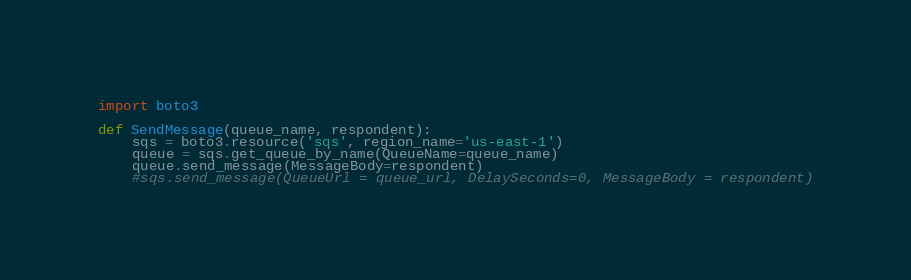Convert code to text. <code><loc_0><loc_0><loc_500><loc_500><_Python_>import boto3

def SendMessage(queue_name, respondent):
    sqs = boto3.resource('sqs', region_name='us-east-1')
    queue = sqs.get_queue_by_name(QueueName=queue_name)
    queue.send_message(MessageBody=respondent)
    #sqs.send_message(QueueUrl = queue_url, DelaySeconds=0, MessageBody = respondent)

</code> 